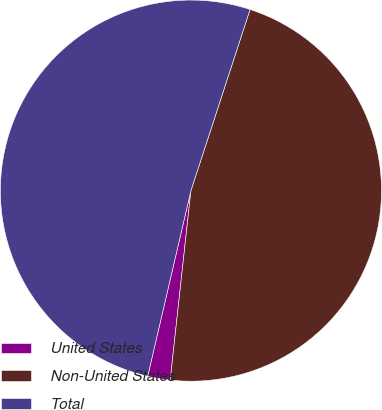<chart> <loc_0><loc_0><loc_500><loc_500><pie_chart><fcel>United States<fcel>Non-United States<fcel>Total<nl><fcel>1.91%<fcel>46.71%<fcel>51.38%<nl></chart> 